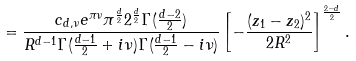<formula> <loc_0><loc_0><loc_500><loc_500>= \frac { c _ { d , \nu } e ^ { \pi \nu } \pi ^ { \frac { d } { 2 } } { 2 ^ { \frac { d } { 2 } } \Gamma ( { \frac { d - 2 } { 2 } } ) } } { R ^ { d - 1 } { \Gamma ( \frac { d - 1 } { 2 } + i \nu ) } { \Gamma ( { \frac { d - 1 } { 2 } } - i \nu ) } } \left [ - \frac { ( z _ { 1 } - z _ { 2 } ) ^ { 2 } } { 2 R ^ { 2 } } \right ] ^ { \frac { 2 - d } { 2 } } .</formula> 